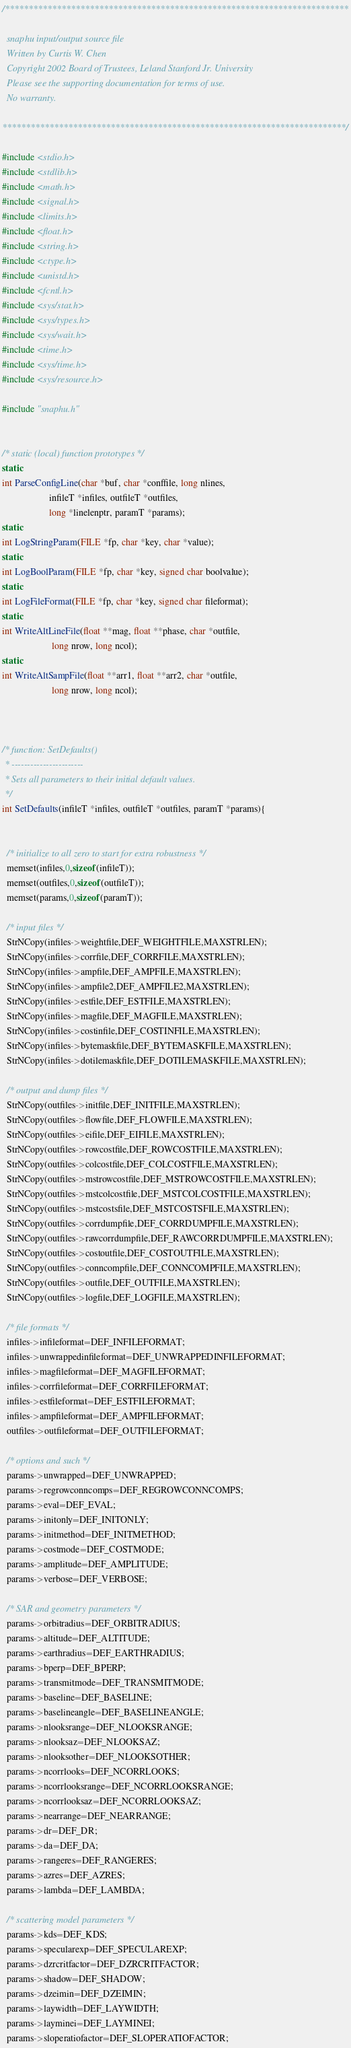<code> <loc_0><loc_0><loc_500><loc_500><_C_>/*************************************************************************

  snaphu input/output source file
  Written by Curtis W. Chen
  Copyright 2002 Board of Trustees, Leland Stanford Jr. University
  Please see the supporting documentation for terms of use.
  No warranty.

*************************************************************************/

#include <stdio.h>
#include <stdlib.h>
#include <math.h>
#include <signal.h>
#include <limits.h>
#include <float.h>
#include <string.h>
#include <ctype.h>
#include <unistd.h>
#include <fcntl.h>
#include <sys/stat.h>
#include <sys/types.h>
#include <sys/wait.h>
#include <time.h>
#include <sys/time.h>
#include <sys/resource.h>

#include "snaphu.h"


/* static (local) function prototypes */
static
int ParseConfigLine(char *buf, char *conffile, long nlines,
                    infileT *infiles, outfileT *outfiles,
                    long *linelenptr, paramT *params);
static
int LogStringParam(FILE *fp, char *key, char *value);
static
int LogBoolParam(FILE *fp, char *key, signed char boolvalue);
static
int LogFileFormat(FILE *fp, char *key, signed char fileformat);
static
int WriteAltLineFile(float **mag, float **phase, char *outfile, 
                     long nrow, long ncol);
static
int WriteAltSampFile(float **arr1, float **arr2, char *outfile, 
                     long nrow, long ncol);



/* function: SetDefaults()
 * -----------------------
 * Sets all parameters to their initial default values.
 */
int SetDefaults(infileT *infiles, outfileT *outfiles, paramT *params){


  /* initialize to all zero to start for extra robustness */
  memset(infiles,0,sizeof(infileT));
  memset(outfiles,0,sizeof(outfileT));
  memset(params,0,sizeof(paramT));
  
  /* input files */
  StrNCopy(infiles->weightfile,DEF_WEIGHTFILE,MAXSTRLEN);
  StrNCopy(infiles->corrfile,DEF_CORRFILE,MAXSTRLEN);
  StrNCopy(infiles->ampfile,DEF_AMPFILE,MAXSTRLEN);
  StrNCopy(infiles->ampfile2,DEF_AMPFILE2,MAXSTRLEN);
  StrNCopy(infiles->estfile,DEF_ESTFILE,MAXSTRLEN);  
  StrNCopy(infiles->magfile,DEF_MAGFILE,MAXSTRLEN);
  StrNCopy(infiles->costinfile,DEF_COSTINFILE,MAXSTRLEN);
  StrNCopy(infiles->bytemaskfile,DEF_BYTEMASKFILE,MAXSTRLEN);
  StrNCopy(infiles->dotilemaskfile,DEF_DOTILEMASKFILE,MAXSTRLEN);

  /* output and dump files */
  StrNCopy(outfiles->initfile,DEF_INITFILE,MAXSTRLEN);
  StrNCopy(outfiles->flowfile,DEF_FLOWFILE,MAXSTRLEN);
  StrNCopy(outfiles->eifile,DEF_EIFILE,MAXSTRLEN);
  StrNCopy(outfiles->rowcostfile,DEF_ROWCOSTFILE,MAXSTRLEN);
  StrNCopy(outfiles->colcostfile,DEF_COLCOSTFILE,MAXSTRLEN);
  StrNCopy(outfiles->mstrowcostfile,DEF_MSTROWCOSTFILE,MAXSTRLEN);
  StrNCopy(outfiles->mstcolcostfile,DEF_MSTCOLCOSTFILE,MAXSTRLEN);
  StrNCopy(outfiles->mstcostsfile,DEF_MSTCOSTSFILE,MAXSTRLEN);
  StrNCopy(outfiles->corrdumpfile,DEF_CORRDUMPFILE,MAXSTRLEN);
  StrNCopy(outfiles->rawcorrdumpfile,DEF_RAWCORRDUMPFILE,MAXSTRLEN);
  StrNCopy(outfiles->costoutfile,DEF_COSTOUTFILE,MAXSTRLEN);
  StrNCopy(outfiles->conncompfile,DEF_CONNCOMPFILE,MAXSTRLEN);
  StrNCopy(outfiles->outfile,DEF_OUTFILE,MAXSTRLEN);  
  StrNCopy(outfiles->logfile,DEF_LOGFILE,MAXSTRLEN);

  /* file formats */
  infiles->infileformat=DEF_INFILEFORMAT;
  infiles->unwrappedinfileformat=DEF_UNWRAPPEDINFILEFORMAT;
  infiles->magfileformat=DEF_MAGFILEFORMAT;
  infiles->corrfileformat=DEF_CORRFILEFORMAT;
  infiles->estfileformat=DEF_ESTFILEFORMAT;
  infiles->ampfileformat=DEF_AMPFILEFORMAT;
  outfiles->outfileformat=DEF_OUTFILEFORMAT;

  /* options and such */
  params->unwrapped=DEF_UNWRAPPED;
  params->regrowconncomps=DEF_REGROWCONNCOMPS;
  params->eval=DEF_EVAL;
  params->initonly=DEF_INITONLY;
  params->initmethod=DEF_INITMETHOD;
  params->costmode=DEF_COSTMODE;
  params->amplitude=DEF_AMPLITUDE;
  params->verbose=DEF_VERBOSE;

  /* SAR and geometry parameters */
  params->orbitradius=DEF_ORBITRADIUS;
  params->altitude=DEF_ALTITUDE;
  params->earthradius=DEF_EARTHRADIUS;
  params->bperp=DEF_BPERP; 
  params->transmitmode=DEF_TRANSMITMODE;
  params->baseline=DEF_BASELINE;
  params->baselineangle=DEF_BASELINEANGLE;
  params->nlooksrange=DEF_NLOOKSRANGE;
  params->nlooksaz=DEF_NLOOKSAZ;
  params->nlooksother=DEF_NLOOKSOTHER;
  params->ncorrlooks=DEF_NCORRLOOKS;           
  params->ncorrlooksrange=DEF_NCORRLOOKSRANGE;
  params->ncorrlooksaz=DEF_NCORRLOOKSAZ;
  params->nearrange=DEF_NEARRANGE;         
  params->dr=DEF_DR;               
  params->da=DEF_DA;               
  params->rangeres=DEF_RANGERES;         
  params->azres=DEF_AZRES;            
  params->lambda=DEF_LAMBDA;           

  /* scattering model parameters */
  params->kds=DEF_KDS;
  params->specularexp=DEF_SPECULAREXP;
  params->dzrcritfactor=DEF_DZRCRITFACTOR;
  params->shadow=DEF_SHADOW;
  params->dzeimin=DEF_DZEIMIN;
  params->laywidth=DEF_LAYWIDTH;
  params->layminei=DEF_LAYMINEI;
  params->sloperatiofactor=DEF_SLOPERATIOFACTOR;</code> 